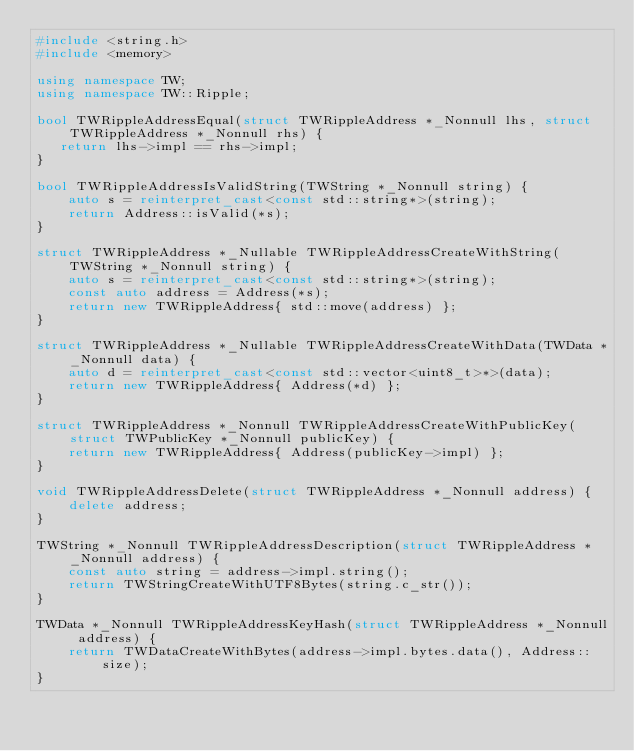Convert code to text. <code><loc_0><loc_0><loc_500><loc_500><_C++_>#include <string.h>
#include <memory>

using namespace TW;
using namespace TW::Ripple;

bool TWRippleAddressEqual(struct TWRippleAddress *_Nonnull lhs, struct TWRippleAddress *_Nonnull rhs) {
   return lhs->impl == rhs->impl;
}

bool TWRippleAddressIsValidString(TWString *_Nonnull string) {
    auto s = reinterpret_cast<const std::string*>(string);
    return Address::isValid(*s);
}

struct TWRippleAddress *_Nullable TWRippleAddressCreateWithString(TWString *_Nonnull string) {
    auto s = reinterpret_cast<const std::string*>(string);
    const auto address = Address(*s);
    return new TWRippleAddress{ std::move(address) };
}

struct TWRippleAddress *_Nullable TWRippleAddressCreateWithData(TWData *_Nonnull data) {
    auto d = reinterpret_cast<const std::vector<uint8_t>*>(data);
    return new TWRippleAddress{ Address(*d) };
}

struct TWRippleAddress *_Nonnull TWRippleAddressCreateWithPublicKey(struct TWPublicKey *_Nonnull publicKey) {
    return new TWRippleAddress{ Address(publicKey->impl) };
}

void TWRippleAddressDelete(struct TWRippleAddress *_Nonnull address) {
    delete address;
}

TWString *_Nonnull TWRippleAddressDescription(struct TWRippleAddress *_Nonnull address) {
    const auto string = address->impl.string();
    return TWStringCreateWithUTF8Bytes(string.c_str());
}

TWData *_Nonnull TWRippleAddressKeyHash(struct TWRippleAddress *_Nonnull address) {
    return TWDataCreateWithBytes(address->impl.bytes.data(), Address::size);
}
</code> 